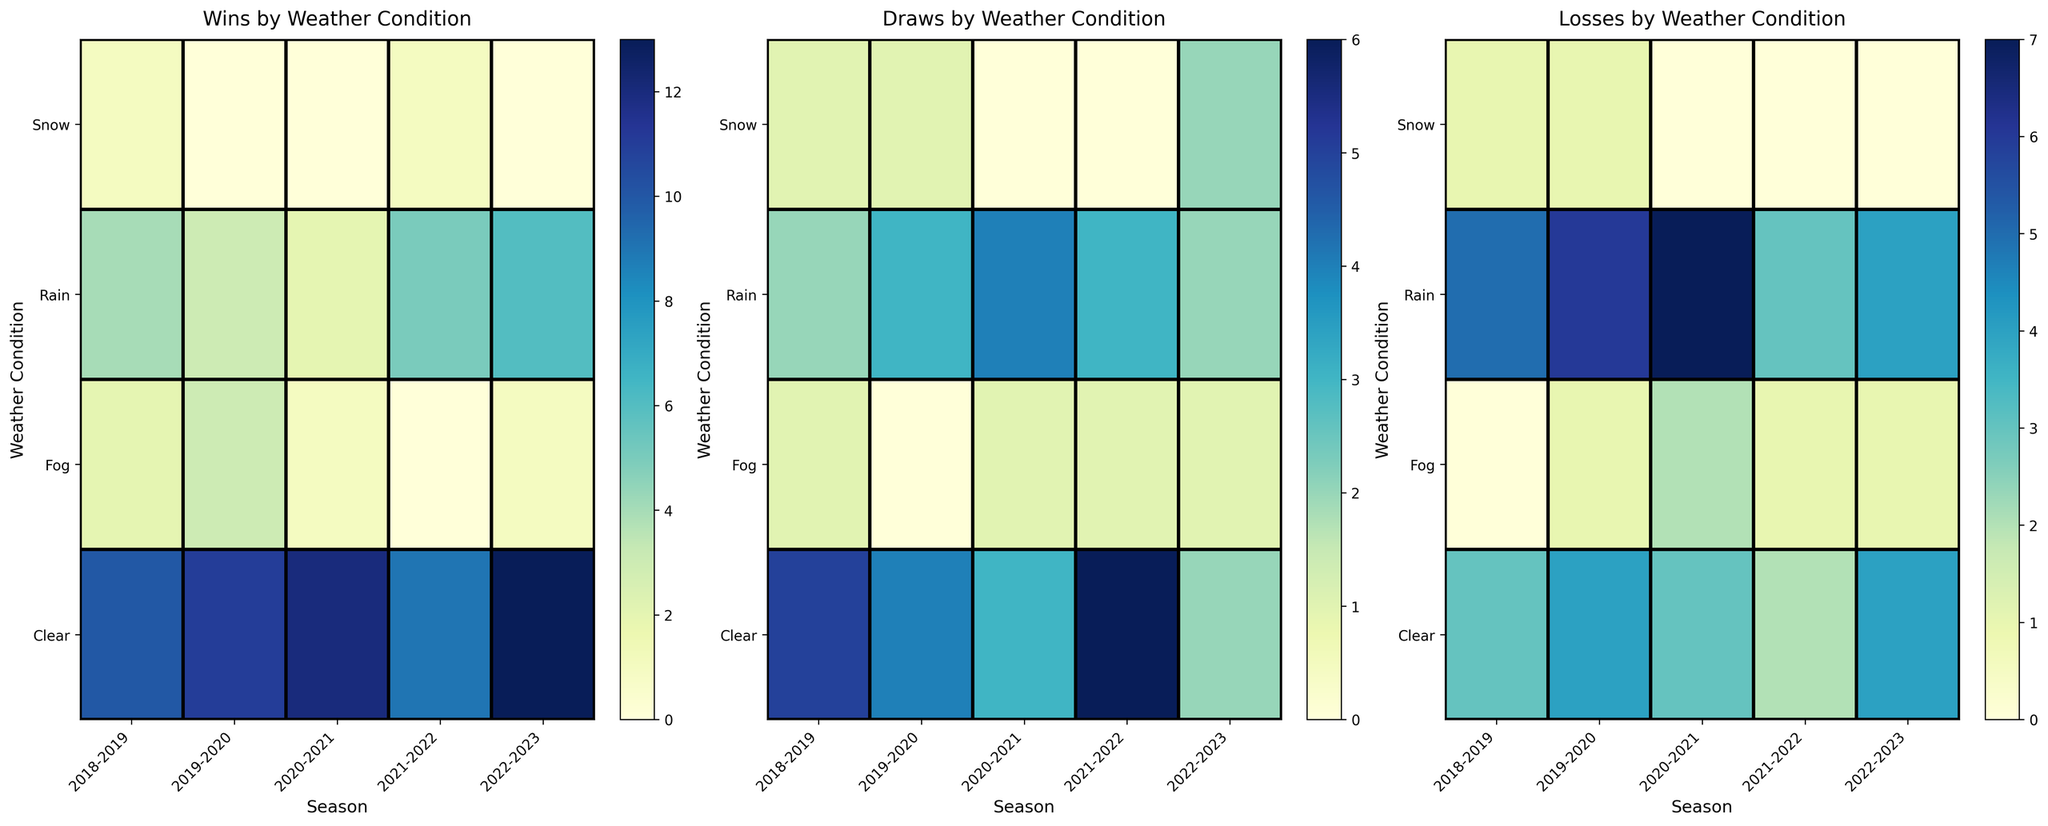Which weather condition had the highest number of wins in the 2020-2021 season? Look at the "Wins by Weather Condition" heatmap and find the highest value under the 2020-2021 column. Clear weather has the highest number of wins with a value of 12.
Answer: Clear In which season did Cambridge United have the most draws in rain conditions? Refer to the "Draws by Weather Condition" heatmap and locate the section for Rain conditions. The highest value under Rain is 4, which is found in the 2020-2021 season.
Answer: 2020-2021 During which weather condition and season did Cambridge United experience the least number of losses? Examine the "Losses by Weather Condition" heatmap and look for the smallest values. The smallest values (0) can be found in the 2018-2019 season for Fog, 2019-2020 season for Snow, and 2020-2021 season for Snow.
Answer: Multiple (Fog 2018-2019, Snow 2019-2020, Snow 2020-2021) What's the total number of wins during clear weather over the five seasons? Sum the values for clear weather in the "Wins by Weather Condition" heatmap: 10 + 11 + 12 + 9 + 13. This gives 10 + 11 = 21, 21 + 12 = 33, 33 + 9 = 42, 42 + 13 = 55.
Answer: 55 Which season had the lowest number of losses in rain conditions and how many? Refer to the "Losses by Weather Condition" heatmap and find the lowest value under Rain conditions. The lowest value is 3 in the 2021-2022 season.
Answer: 2021-2022, 3 How many wins did Cambridge United achieve in foggy conditions across all five seasons? Sum the values for fog in the "Wins by Weather Condition" heatmap: 2 + 3 + 1 + 0 + 1. This gives 2 + 3 = 5, 5 + 1 = 6, 6 + 0 = 6, 6 + 1 = 7.
Answer: 7 Compare the number of losses in clear weather during the 2021-2022 and 2022-2023 seasons. Which season had fewer losses? Check the "Losses by Weather Condition" heatmap for the values under Clear conditions for the respective seasons. In 2021-2022, it's 2, and in 2022-2023, it's 4.
Answer: 2021-2022 What is the difference in the number of draws between snow and fog conditions in the 2022-2023 season? Refer to the "Draws by Weather Condition" heatmap for 2022-2023. The value for Snow is 2, and for Fog it is 1. The difference is 2 - 1 = 1.
Answer: 1 